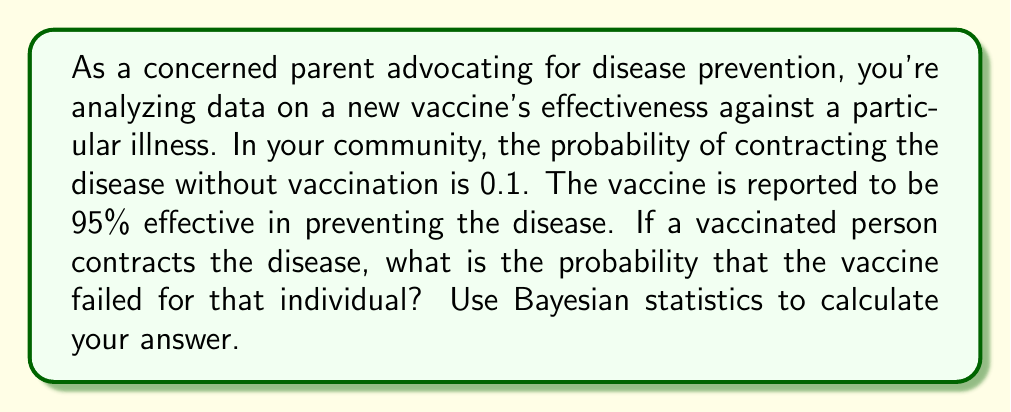Show me your answer to this math problem. Let's approach this problem using Bayesian statistics:

1) Define our events:
   A: The person contracts the disease
   B: The vaccine failed

2) We're given:
   P(A) = 0.1 (probability of contracting the disease without vaccination)
   P(B) = 0.05 (probability of vaccine failure, since it's 95% effective)
   P(A|B) = 1 (probability of contracting the disease if the vaccine failed)

3) We want to find P(B|A), which is the probability that the vaccine failed given that the person contracted the disease.

4) Bayes' theorem states:

   $$P(B|A) = \frac{P(A|B) \cdot P(B)}{P(A)}$$

5) We know P(A|B) and P(B), but we need to calculate P(A) for a vaccinated person:

   P(A) = P(A|B) * P(B) + P(A|not B) * P(not B)
        = 1 * 0.05 + 0.1 * 0.95
        = 0.05 + 0.095
        = 0.145

6) Now we can apply Bayes' theorem:

   $$P(B|A) = \frac{1 \cdot 0.05}{0.145} \approx 0.3448$$

7) Convert to a percentage: 0.3448 * 100 ≈ 34.48%
Answer: The probability that the vaccine failed for a vaccinated person who contracted the disease is approximately 34.48%. 